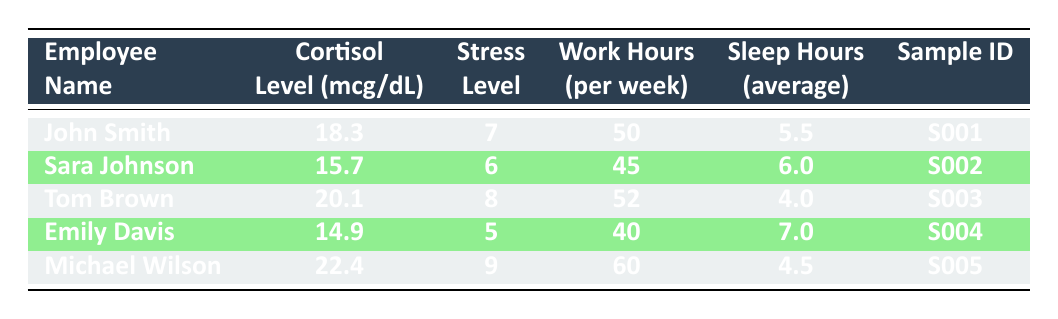What is the cortisol level of Tom Brown? Tom Brown's cortisol level is directly listed under the "Cortisol Level (mcg/dL)" column in the table. The value for his sample ID S003 is 20.1 mcg/dL.
Answer: 20.1 mcg/dL Who reported the highest stress level? To determine who reported the highest stress level, we can look at the "Stress Level" column. The highest reported stress level is 9, which corresponds to Michael Wilson (Sample ID S005).
Answer: Michael Wilson What is the average sleep hours of all employees? To calculate the average sleep hours, we sum the sleep hours of all employees: (5.5 + 6 + 4 + 7 + 4.5) = 27. The number of employees is 5. Thus, the average sleep hours is 27/5 = 5.4.
Answer: 5.4 Is Sara Johnson's cortisol level above 17 mcg/dL? Sara Johnson's cortisol level is 15.7 mcg/dL, which is below 17 mcg/dL according to the "Cortisol Level (mcg/dL)" column.
Answer: No What is the difference in cortisol levels between the highest and lowest recorded? The highest cortisol level is 22.4 mcg/dL (Michael Wilson) and the lowest is 14.9 mcg/dL (Emily Davis). The difference is 22.4 - 14.9 = 7.5 mcg/dL.
Answer: 7.5 mcg/dL What are the work hours of the employee with the highest self-reported stress level? The employee with the highest self-reported stress level is Michael Wilson, who has a stress level of 9. Looking in the "Work Hours (per week)" column, his work hours are 60.
Answer: 60 How many employees work more than 50 hours per week? In the "Work Hours (per week)" column, we identify the employees working more than 50 hours. Only Tom Brown (52) and Michael Wilson (60) meet this condition, so there are 2 employees.
Answer: 2 Is there any employee who sleeps less than 5 hours on average? Checking the "Sleep Hours (average)" column, we see Tom Brown with an average of 4 hours, which is less than 5 hours. Therefore, the answer is yes.
Answer: Yes 